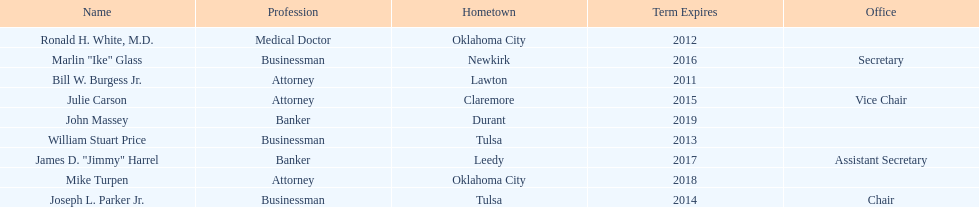Other members of the state regents from tulsa besides joseph l. parker jr. William Stuart Price. 